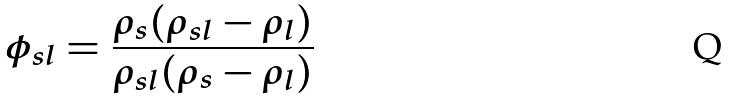Convert formula to latex. <formula><loc_0><loc_0><loc_500><loc_500>\phi _ { s l } = \frac { \rho _ { s } ( \rho _ { s l } - \rho _ { l } ) } { \rho _ { s l } ( \rho _ { s } - \rho _ { l } ) }</formula> 